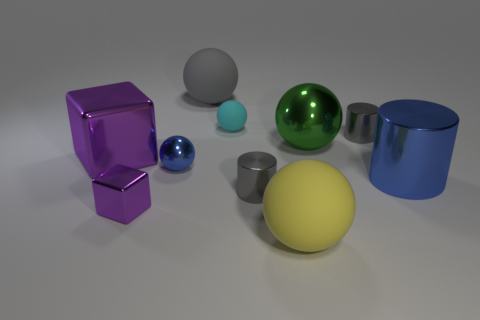The object that is the same color as the large shiny cylinder is what size?
Ensure brevity in your answer.  Small. What number of other things are the same size as the green metallic thing?
Your response must be concise. 4. What is the material of the cylinder that is on the left side of the green metal sphere?
Make the answer very short. Metal. There is a small gray metal thing behind the blue metal thing to the left of the cyan ball that is behind the tiny shiny sphere; what shape is it?
Give a very brief answer. Cylinder. Do the green object and the blue sphere have the same size?
Keep it short and to the point. No. How many objects are big yellow matte cylinders or tiny gray metal things behind the blue metallic cylinder?
Make the answer very short. 1. How many things are big metal cylinders that are to the right of the yellow thing or tiny purple blocks that are on the left side of the yellow matte sphere?
Provide a short and direct response. 2. Are there any small blue metallic spheres on the left side of the small matte ball?
Offer a terse response. Yes. The cube in front of the gray metal thing that is left of the big matte object to the right of the gray ball is what color?
Make the answer very short. Purple. Is the shape of the big yellow rubber object the same as the green object?
Keep it short and to the point. Yes. 